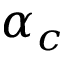<formula> <loc_0><loc_0><loc_500><loc_500>\alpha _ { c }</formula> 